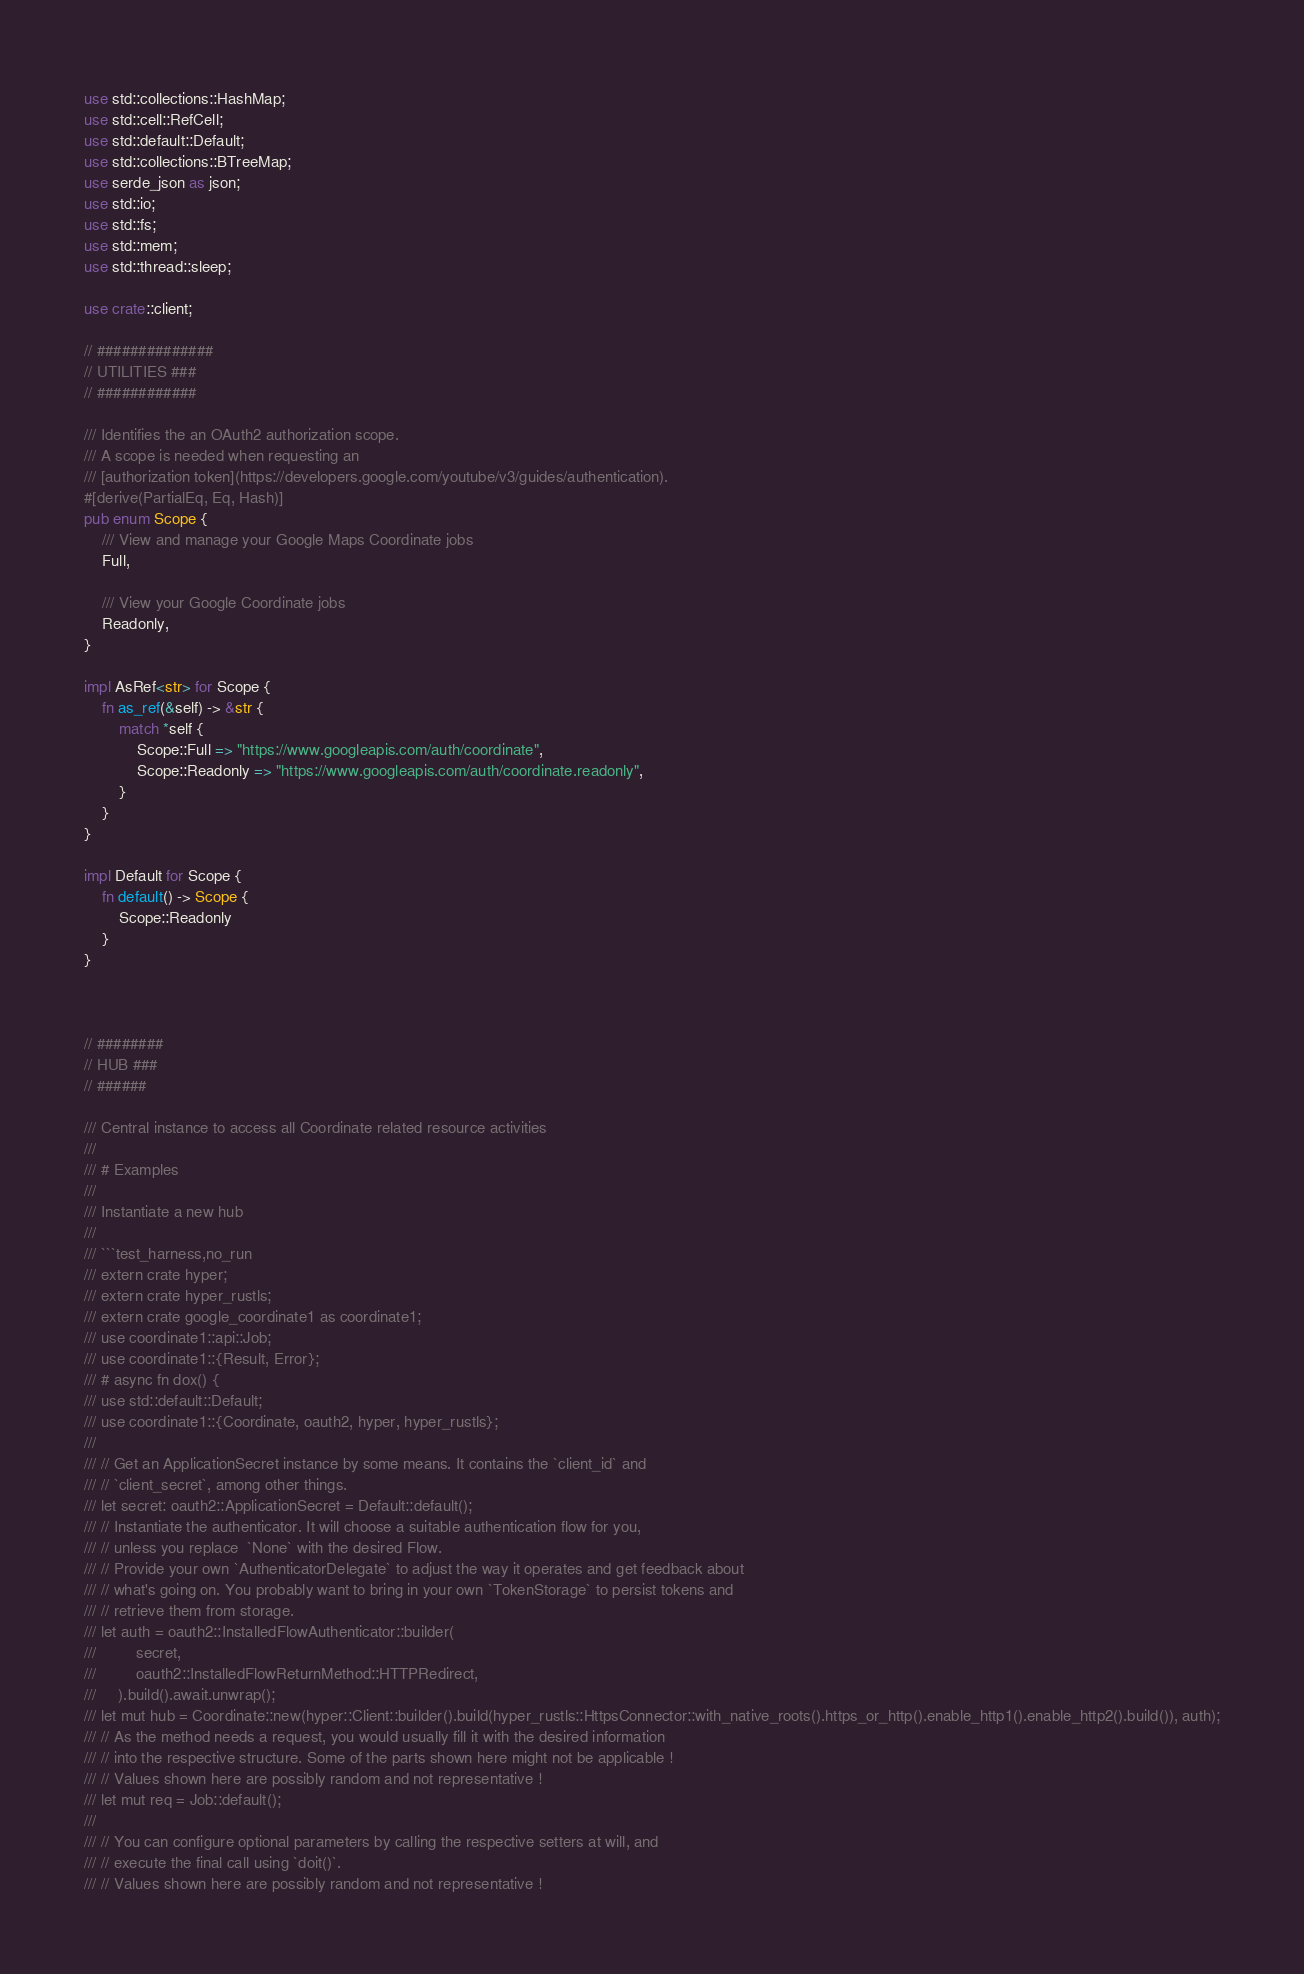<code> <loc_0><loc_0><loc_500><loc_500><_Rust_>use std::collections::HashMap;
use std::cell::RefCell;
use std::default::Default;
use std::collections::BTreeMap;
use serde_json as json;
use std::io;
use std::fs;
use std::mem;
use std::thread::sleep;

use crate::client;

// ##############
// UTILITIES ###
// ############

/// Identifies the an OAuth2 authorization scope.
/// A scope is needed when requesting an
/// [authorization token](https://developers.google.com/youtube/v3/guides/authentication).
#[derive(PartialEq, Eq, Hash)]
pub enum Scope {
    /// View and manage your Google Maps Coordinate jobs
    Full,

    /// View your Google Coordinate jobs
    Readonly,
}

impl AsRef<str> for Scope {
    fn as_ref(&self) -> &str {
        match *self {
            Scope::Full => "https://www.googleapis.com/auth/coordinate",
            Scope::Readonly => "https://www.googleapis.com/auth/coordinate.readonly",
        }
    }
}

impl Default for Scope {
    fn default() -> Scope {
        Scope::Readonly
    }
}



// ########
// HUB ###
// ######

/// Central instance to access all Coordinate related resource activities
///
/// # Examples
///
/// Instantiate a new hub
///
/// ```test_harness,no_run
/// extern crate hyper;
/// extern crate hyper_rustls;
/// extern crate google_coordinate1 as coordinate1;
/// use coordinate1::api::Job;
/// use coordinate1::{Result, Error};
/// # async fn dox() {
/// use std::default::Default;
/// use coordinate1::{Coordinate, oauth2, hyper, hyper_rustls};
/// 
/// // Get an ApplicationSecret instance by some means. It contains the `client_id` and 
/// // `client_secret`, among other things.
/// let secret: oauth2::ApplicationSecret = Default::default();
/// // Instantiate the authenticator. It will choose a suitable authentication flow for you, 
/// // unless you replace  `None` with the desired Flow.
/// // Provide your own `AuthenticatorDelegate` to adjust the way it operates and get feedback about 
/// // what's going on. You probably want to bring in your own `TokenStorage` to persist tokens and
/// // retrieve them from storage.
/// let auth = oauth2::InstalledFlowAuthenticator::builder(
///         secret,
///         oauth2::InstalledFlowReturnMethod::HTTPRedirect,
///     ).build().await.unwrap();
/// let mut hub = Coordinate::new(hyper::Client::builder().build(hyper_rustls::HttpsConnector::with_native_roots().https_or_http().enable_http1().enable_http2().build()), auth);
/// // As the method needs a request, you would usually fill it with the desired information
/// // into the respective structure. Some of the parts shown here might not be applicable !
/// // Values shown here are possibly random and not representative !
/// let mut req = Job::default();
/// 
/// // You can configure optional parameters by calling the respective setters at will, and
/// // execute the final call using `doit()`.
/// // Values shown here are possibly random and not representative !</code> 